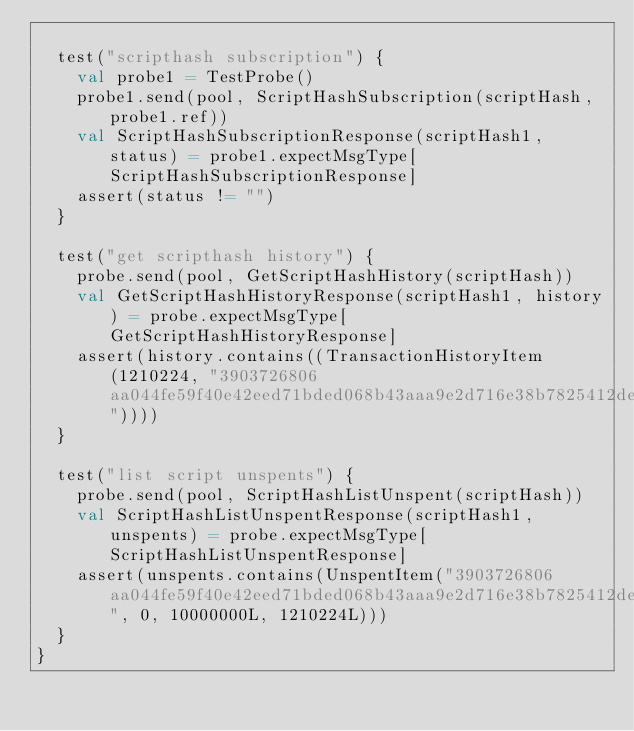Convert code to text. <code><loc_0><loc_0><loc_500><loc_500><_Scala_>
  test("scripthash subscription") {
    val probe1 = TestProbe()
    probe1.send(pool, ScriptHashSubscription(scriptHash, probe1.ref))
    val ScriptHashSubscriptionResponse(scriptHash1, status) = probe1.expectMsgType[ScriptHashSubscriptionResponse]
    assert(status != "")
  }

  test("get scripthash history") {
    probe.send(pool, GetScriptHashHistory(scriptHash))
    val GetScriptHashHistoryResponse(scriptHash1, history) = probe.expectMsgType[GetScriptHashHistoryResponse]
    assert(history.contains((TransactionHistoryItem(1210224, "3903726806aa044fe59f40e42eed71bded068b43aaa9e2d716e38b7825412de0"))))
  }

  test("list script unspents") {
    probe.send(pool, ScriptHashListUnspent(scriptHash))
    val ScriptHashListUnspentResponse(scriptHash1, unspents) = probe.expectMsgType[ScriptHashListUnspentResponse]
    assert(unspents.contains(UnspentItem("3903726806aa044fe59f40e42eed71bded068b43aaa9e2d716e38b7825412de0", 0, 10000000L, 1210224L)))
  }
}
</code> 